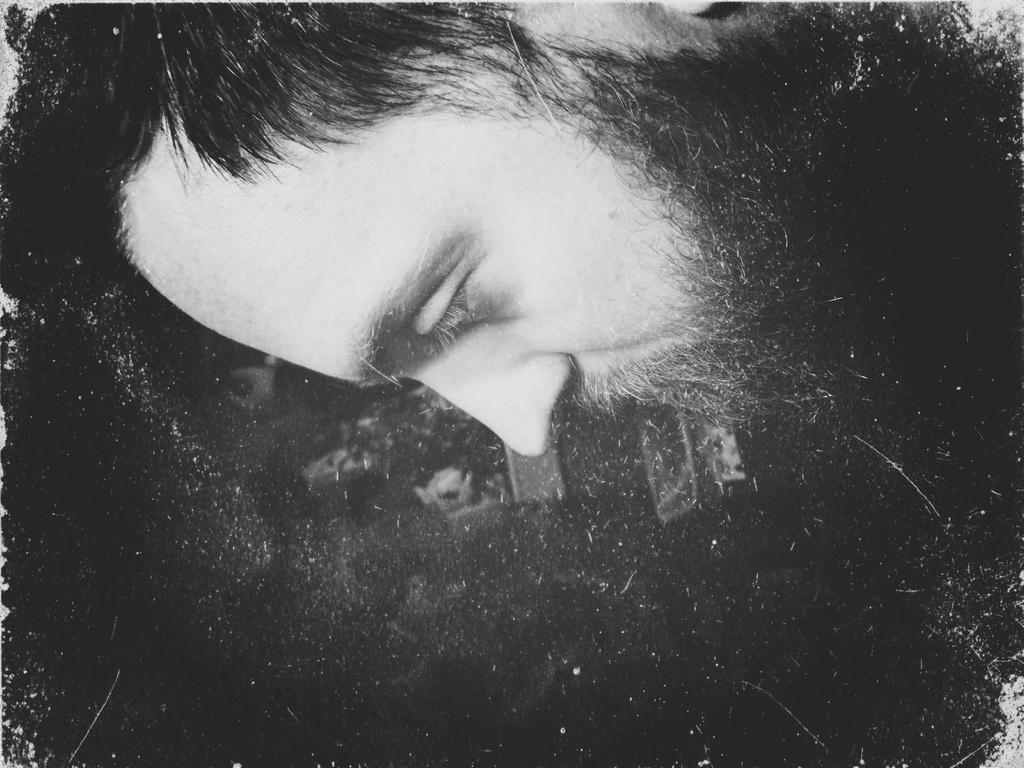What is the color scheme of the image? The image is a black and white picture. What is the main subject of the image? The picture depicts a person. Can you tell me how many apples the girl is holding in the image? There is no girl or apple present in the image; it is a black and white picture of a person. 